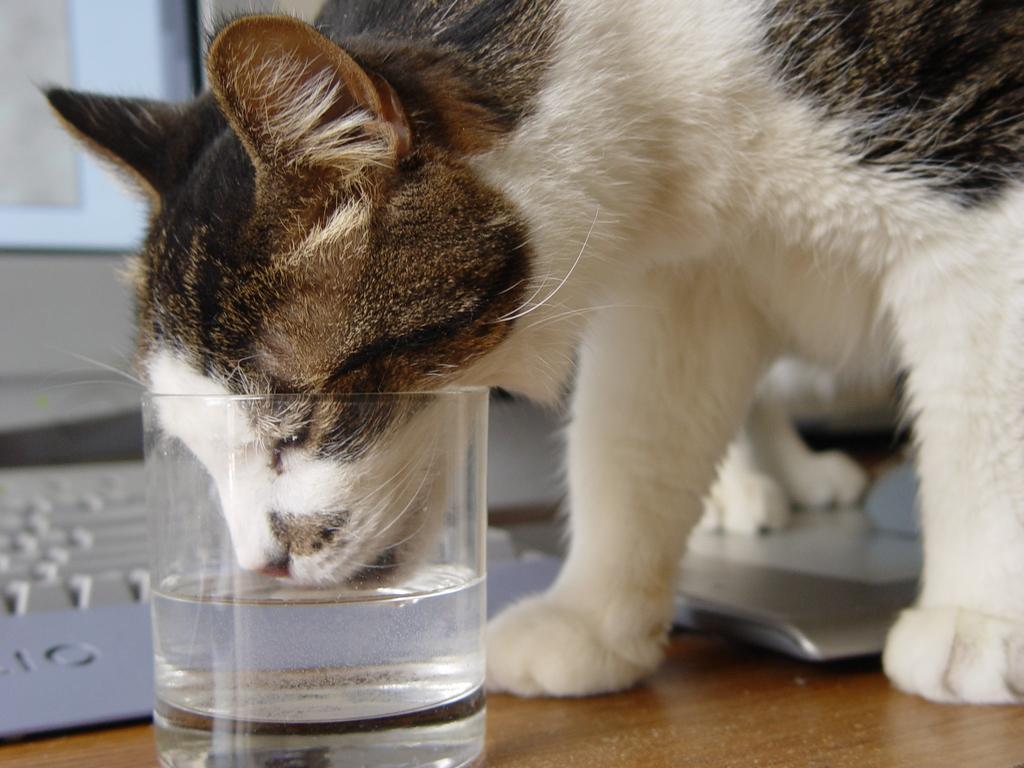Describe this image in one or two sentences. This is the picture of a cat which is drinking the water which are in the glass and also we can see a laptop to the side. 